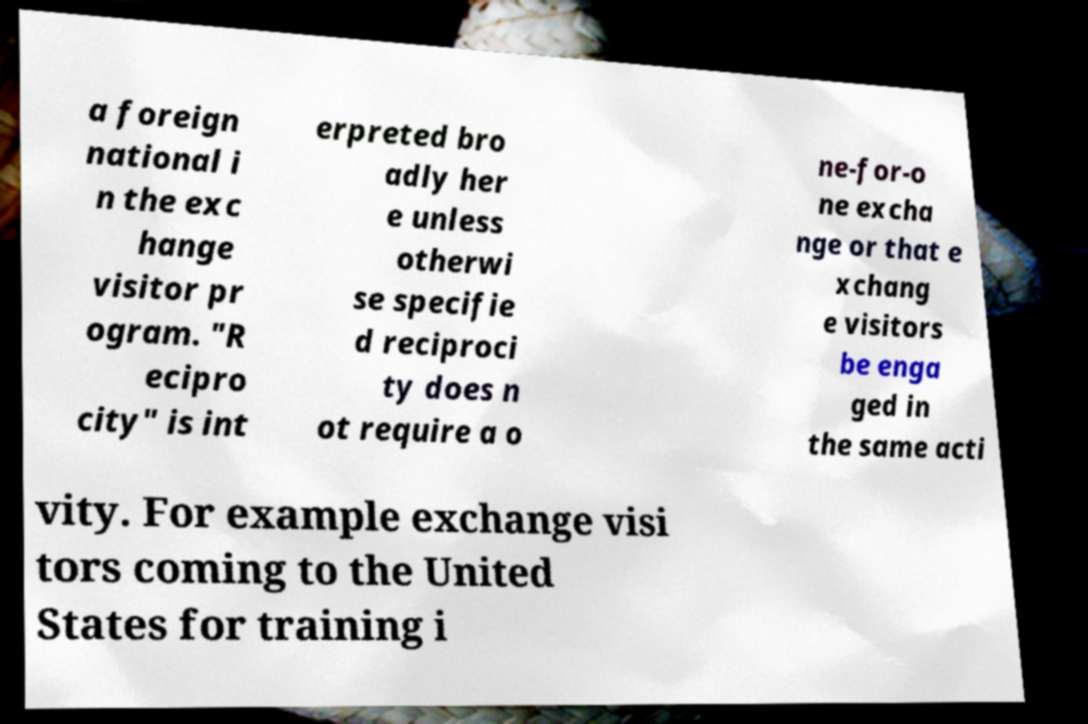Please read and relay the text visible in this image. What does it say? a foreign national i n the exc hange visitor pr ogram. "R ecipro city" is int erpreted bro adly her e unless otherwi se specifie d reciproci ty does n ot require a o ne-for-o ne excha nge or that e xchang e visitors be enga ged in the same acti vity. For example exchange visi tors coming to the United States for training i 